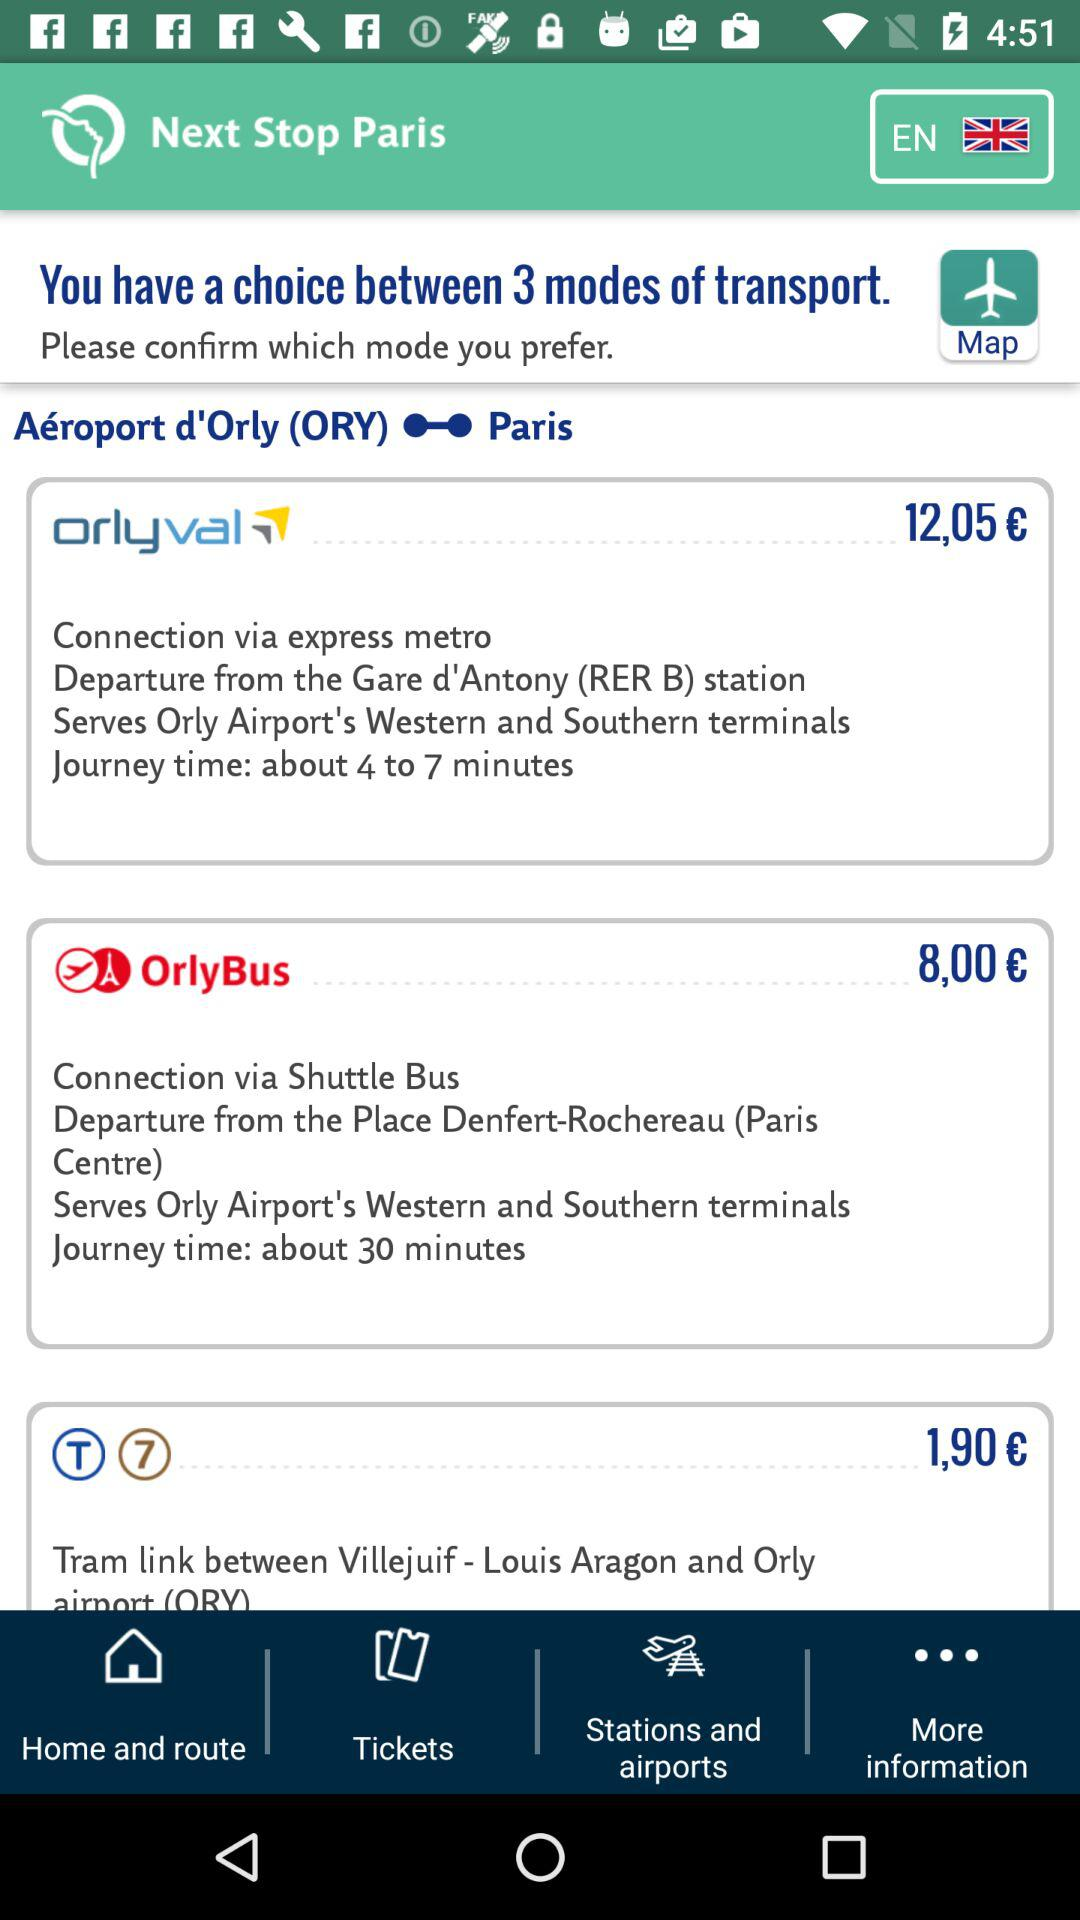How much is the cheapest mode of transport to get to Orly airport?
Answer the question using a single word or phrase. 1,90 € 